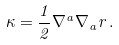<formula> <loc_0><loc_0><loc_500><loc_500>\kappa = \frac { 1 } { 2 } \nabla ^ { a } \nabla _ { a } r \, .</formula> 